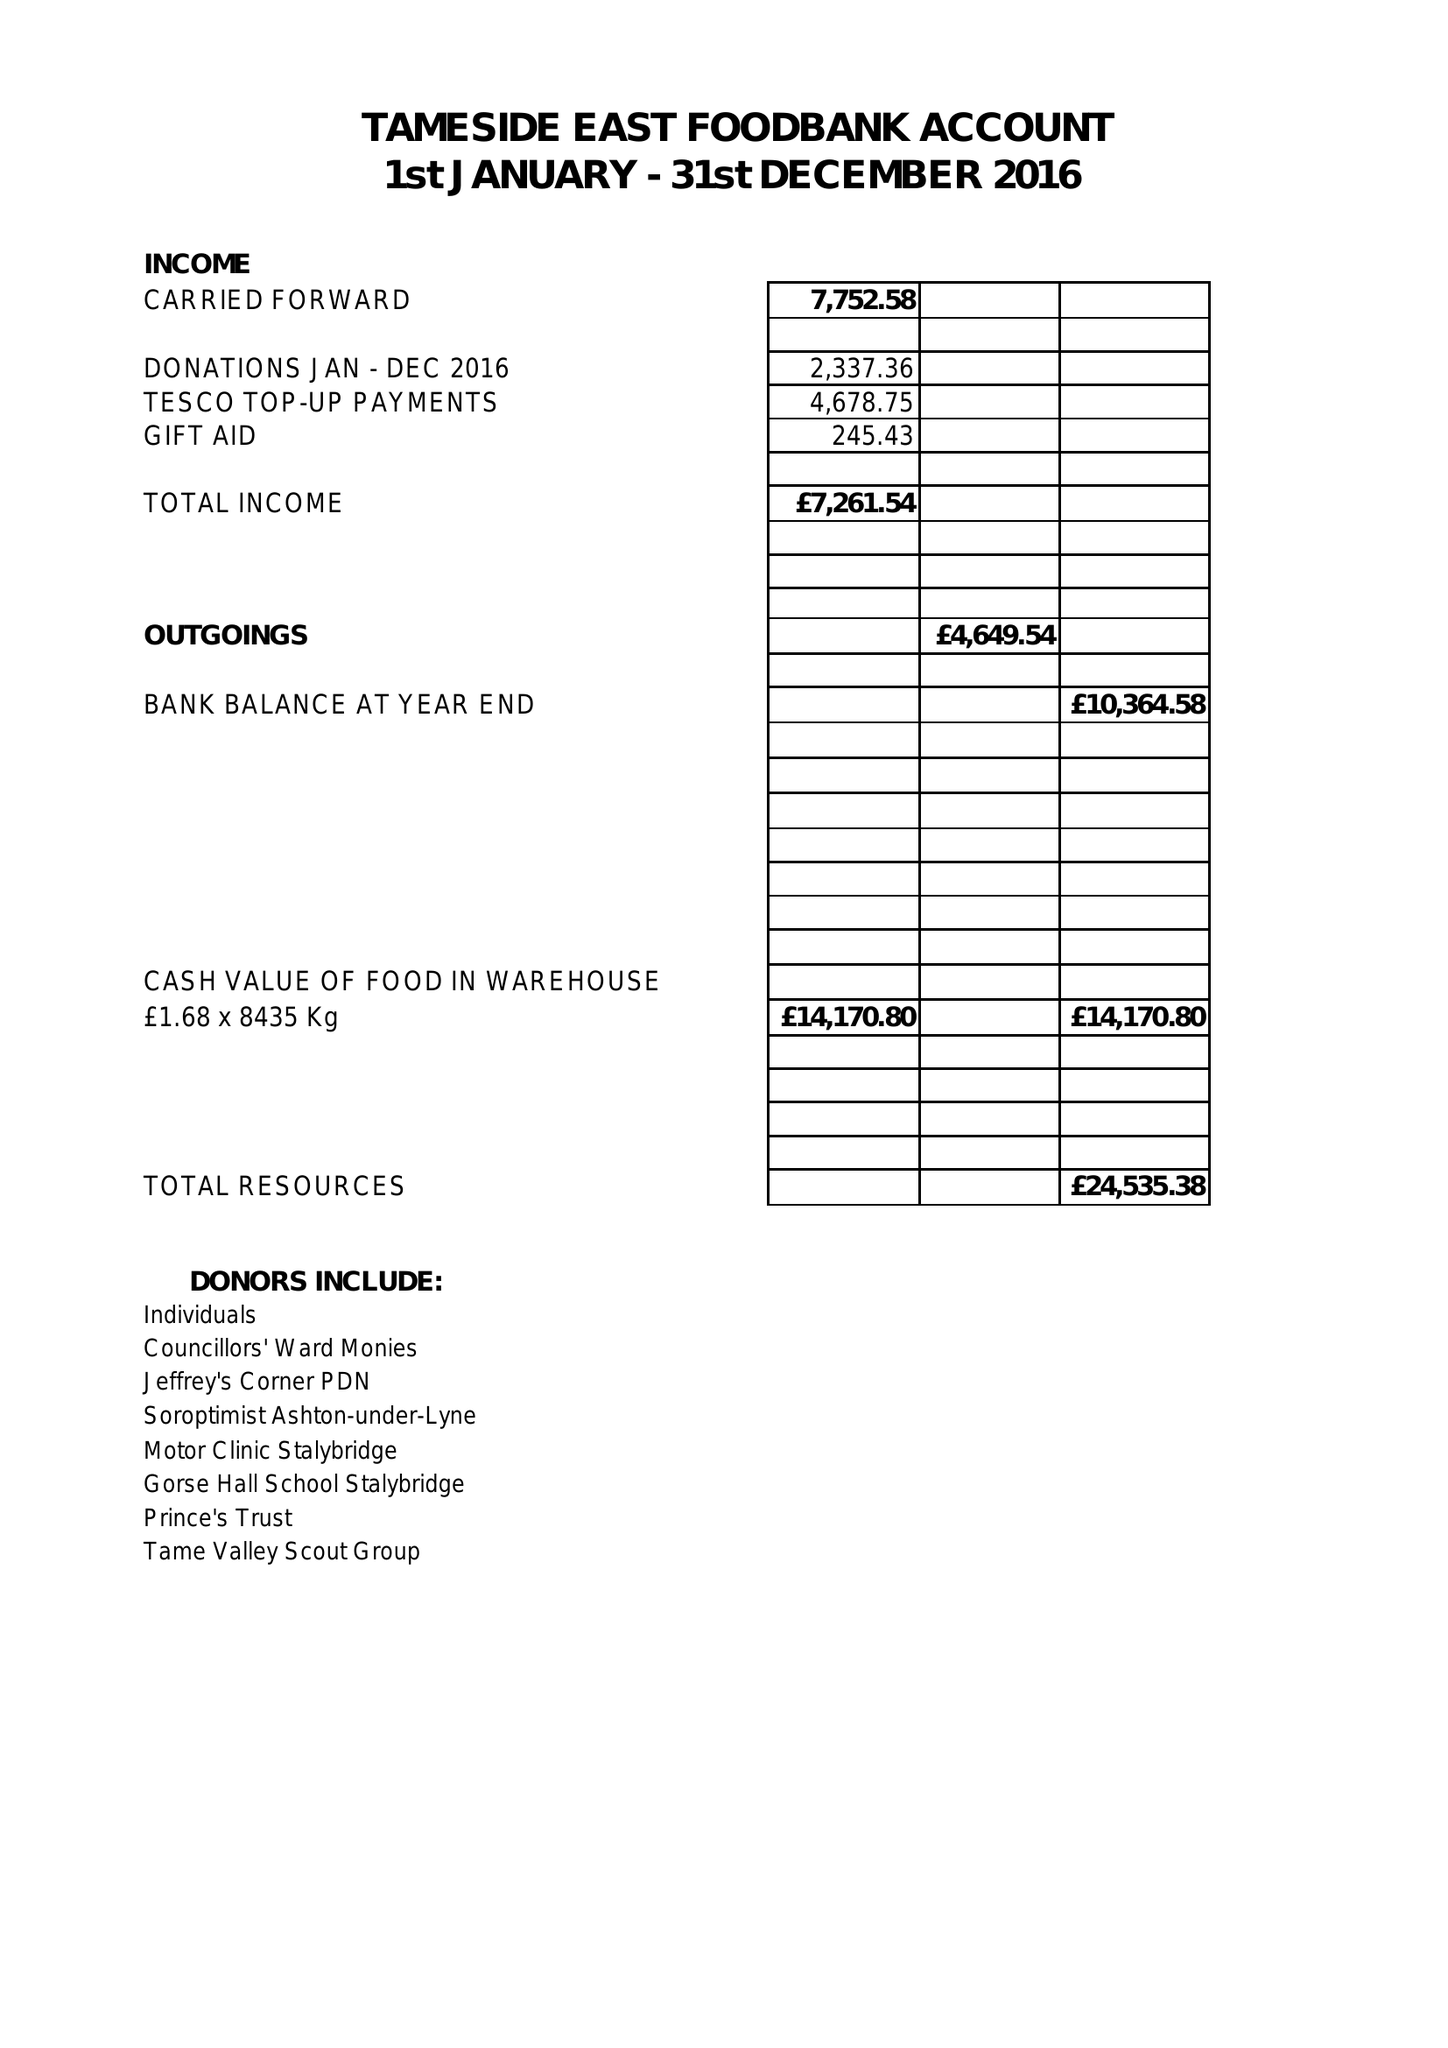What is the value for the charity_name?
Answer the question using a single word or phrase. Tameside East Foodbank 